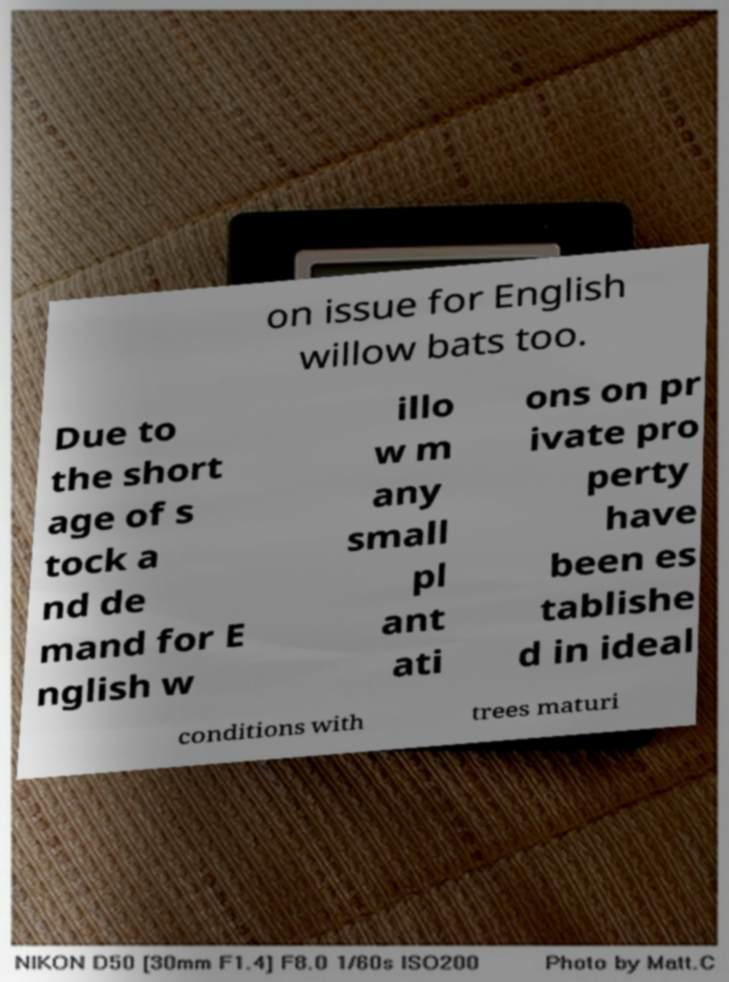There's text embedded in this image that I need extracted. Can you transcribe it verbatim? on issue for English willow bats too. Due to the short age of s tock a nd de mand for E nglish w illo w m any small pl ant ati ons on pr ivate pro perty have been es tablishe d in ideal conditions with trees maturi 